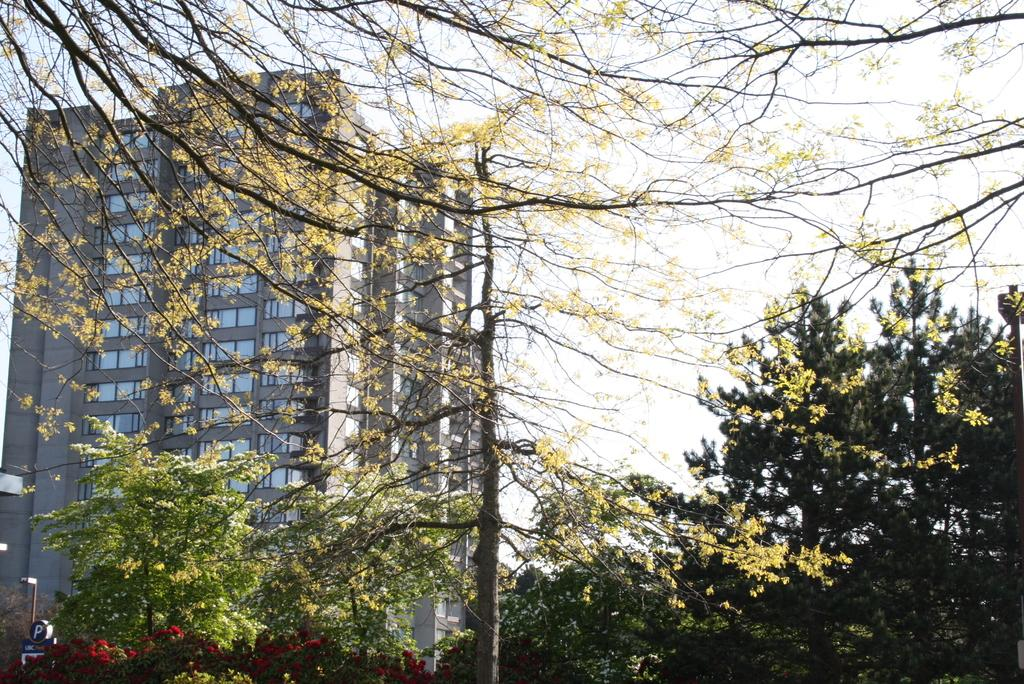What type of vegetation can be seen in the image? There are trees and plants with flowers in the image. What structure is located on the left side of the image? There is a building on the left side of the image. What is the pole used for in the image? The purpose of the pole is not clear from the image, but it could be a utility pole or a decorative element. How many windows are visible in the image? There are windows in the image, but the exact number is not specified. What object is present in the image? There is an object in the image, but its description is not provided. What can be seen in the background of the image? The sky is visible in the background of the image. How many girls are holding quills in the image? There are no girls or quills present in the image. What type of stone is used to build the building in the image? The type of stone used to build the building is not specified in the image. 